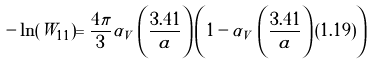Convert formula to latex. <formula><loc_0><loc_0><loc_500><loc_500>- \ln ( W _ { 1 1 } ) = \frac { 4 \pi } { 3 } \alpha _ { V } \, \left ( \frac { 3 . 4 1 } { a } \right ) \left ( 1 - \alpha _ { V } \, \left ( \frac { 3 . 4 1 } { a } \right ) ( 1 . 1 9 ) \right )</formula> 